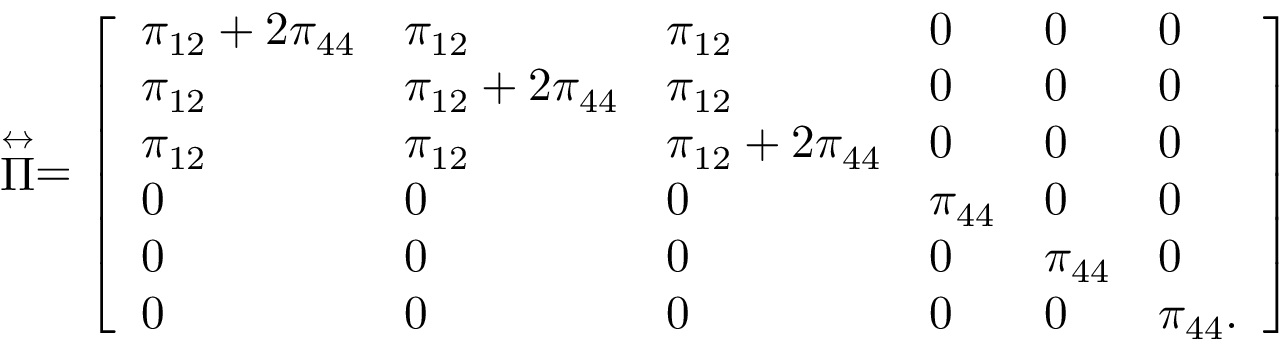<formula> <loc_0><loc_0><loc_500><loc_500>\stackrel { \leftrightarrow } { \Pi } = \left [ \begin{array} { l l l l l l } { \pi _ { 1 2 } + 2 \pi _ { 4 4 } } & { \pi _ { 1 2 } } & { \pi _ { 1 2 } } & { 0 } & { 0 } & { 0 } \\ { \pi _ { 1 2 } } & { \pi _ { 1 2 } + 2 \pi _ { 4 4 } } & { \pi _ { 1 2 } } & { 0 } & { 0 } & { 0 } \\ { \pi _ { 1 2 } } & { \pi _ { 1 2 } } & { \pi _ { 1 2 } + 2 \pi _ { 4 4 } } & { 0 } & { 0 } & { 0 } \\ { 0 } & { 0 } & { 0 } & { \pi _ { 4 4 } } & { 0 } & { 0 } \\ { 0 } & { 0 } & { 0 } & { 0 } & { \pi _ { 4 4 } } & { 0 } \\ { 0 } & { 0 } & { 0 } & { 0 } & { 0 } & { \pi _ { 4 4 } . } \end{array} \right ]</formula> 